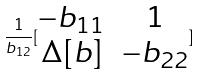Convert formula to latex. <formula><loc_0><loc_0><loc_500><loc_500>\frac { 1 } { b _ { 1 2 } } [ \begin{matrix} - b _ { 1 1 } & 1 \\ \Delta [ b ] & - b _ { 2 2 } \end{matrix} ]</formula> 